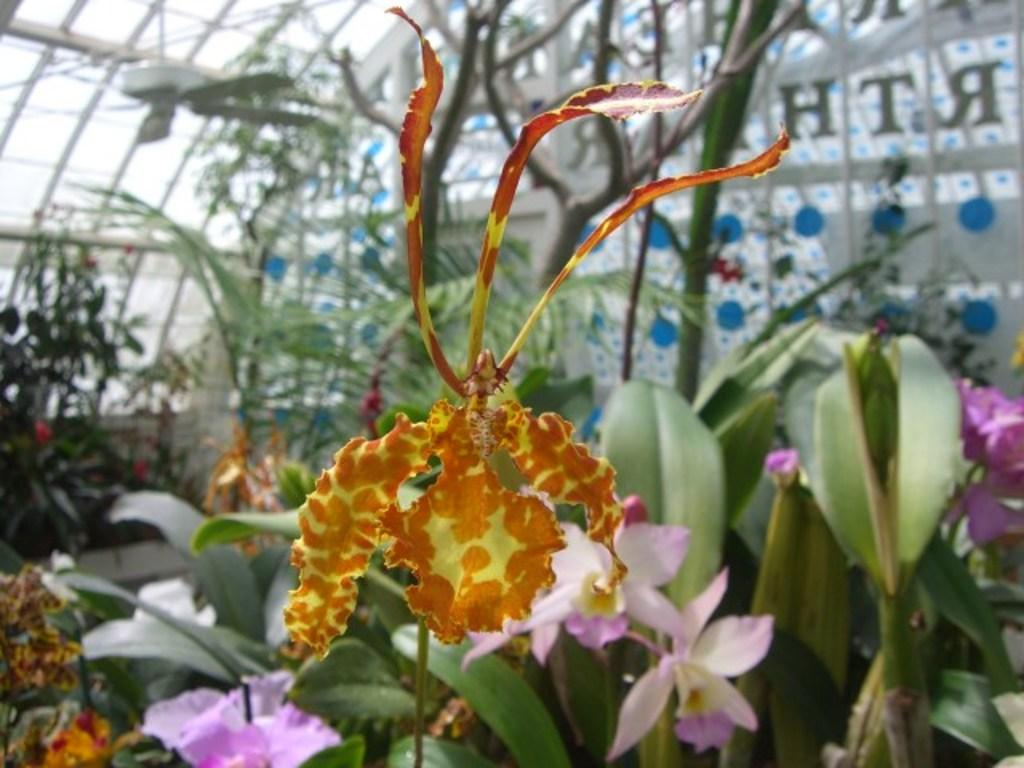What types of living organisms can be seen in the image? Plants and flowers are visible in the image. What is the purpose of the fan in the image? The fan is likely used for cooling or ventilation. Can you describe the glass with text in the background of the image? The glass with text is visible in the background, but its content cannot be determined from the image. What is the level of wealth depicted in the image? There is no indication of wealth in the image, as it features plants, flowers, a fan, and a glass with text. What type of engine can be seen in the image? There is no engine present in the image. 